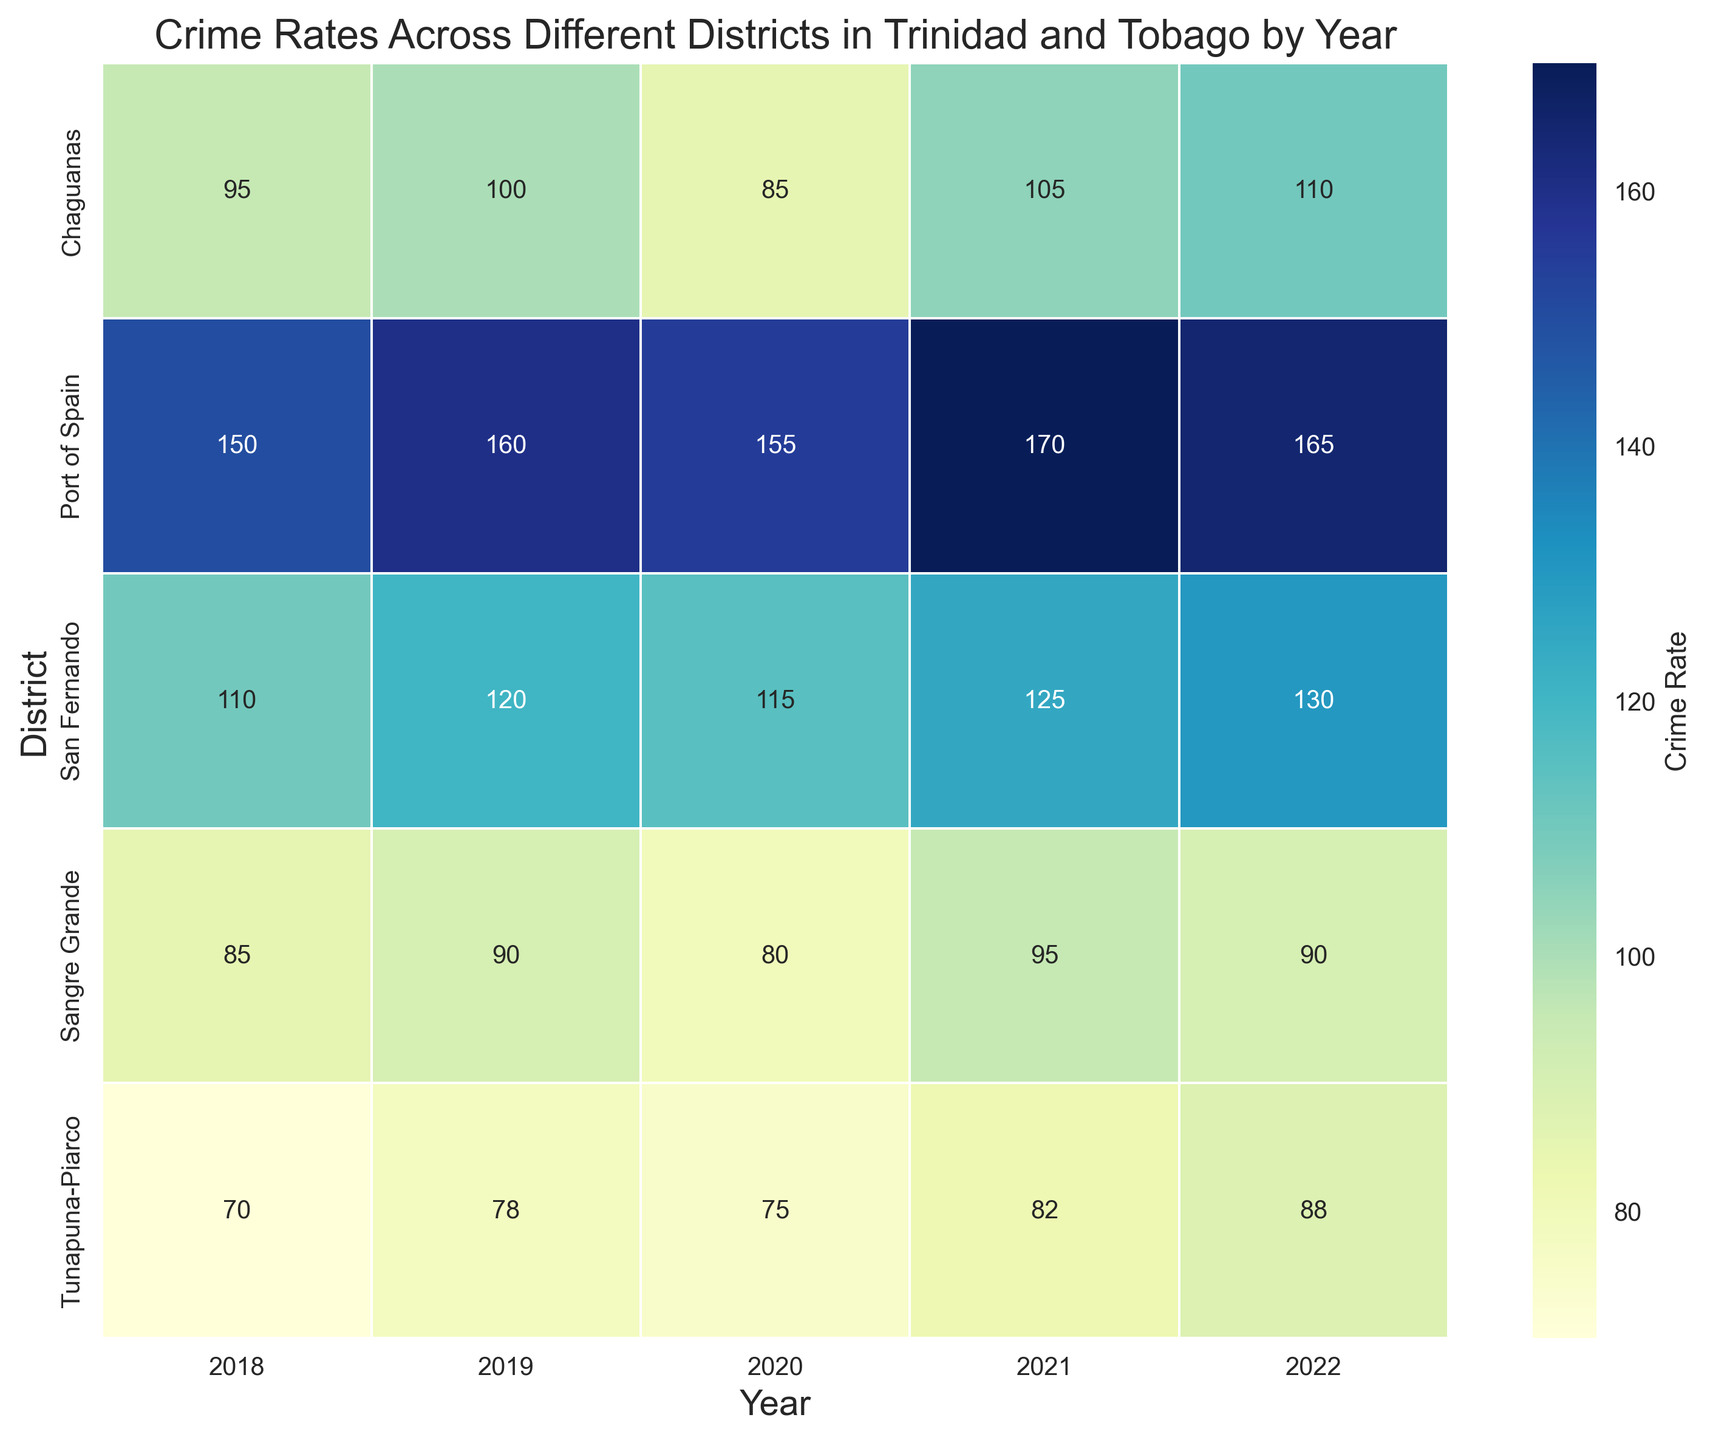Which district has the highest crime rate in 2022? The highest crime rate in 2022 can be found by looking at the darkest cell in the row for 2022. Port of Spain has the value 165, which is the highest.
Answer: Port of Spain What is the overall trend in crime rates in Port of Spain over the years 2018-2022? By examining the crime rate values for Port of Spain from 2018 to 2022, we observe the following values: 150, 160, 155, 170, 165. They generally increase, peak in 2021, and then slightly decrease in 2022.
Answer: Increasing, then slight decline in 2022 Which year shows the highest crime rate for San Fernando? By examining the values for San Fernando across the years 2018-2022, the highest value is 130 in the year 2022.
Answer: 2022 Calculate the average crime rate in Chaguanas from 2018 to 2022. To find the average, add the crime rates from 2018 to 2022: 95 + 100 + 85 + 105 + 110 = 495. Divide by the number of years, 5. 495 / 5 = 99.
Answer: 99 Is the crime rate in 2020 for Tunapuna-Piarco higher or lower than in 2019? For Tunapuna-Piarco, the crime rate in 2019 is 78, and in 2020 it is 75. Hence, the crime rate in 2020 is lower.
Answer: Lower Which district has the least variation in crime rates over the years? By comparing the crime rates for each district across the years 2018-2022, Tunapuna-Piarco shows relatively consistent values ranging from 70 to 88, indicating the least variation.
Answer: Tunapuna-Piarco What is the total crime rate in Sangre Grande for the years 2018 and 2019 combined? To find the total, add the crime rates for Sangre Grande in 2018 and 2019: 85 + 90 = 175.
Answer: 175 Compare the crime rate trend in Chaguanas and San Fernando over the years 2018-2022. Which one has a steeper increase? The crime rates for Chaguanas from 2018 to 2022 are: 95, 100, 85, 105, and 110. For San Fernando, they are: 110, 120, 115, 125, and 130. San Fernando shows a more consistent and steeper increase compared to Chaguanas, which has fluctuations.
Answer: San Fernando What is the difference in crime rates between the highest and lowest values in 2021? The highest value in 2021 is 170 (Port of Spain) and the lowest is 82 (Tunapuna-Piarco). The difference is 170 - 82 = 88.
Answer: 88 How has the crime rate in Sangre Grande changed from 2018 to 2022? The crime rates in Sangre Grande over the years 2018-2022 are: 85, 90, 80, 95, 90. The values don't show a clear trend and fluctuate within a small range.
Answer: Fluctuated 